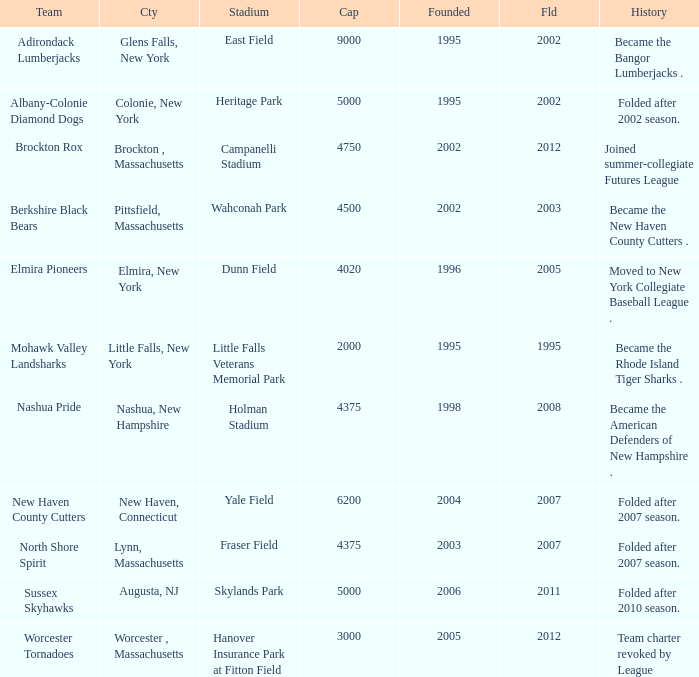What is the maximum folded value of the team whose stadium is Fraser Field? 2007.0. 